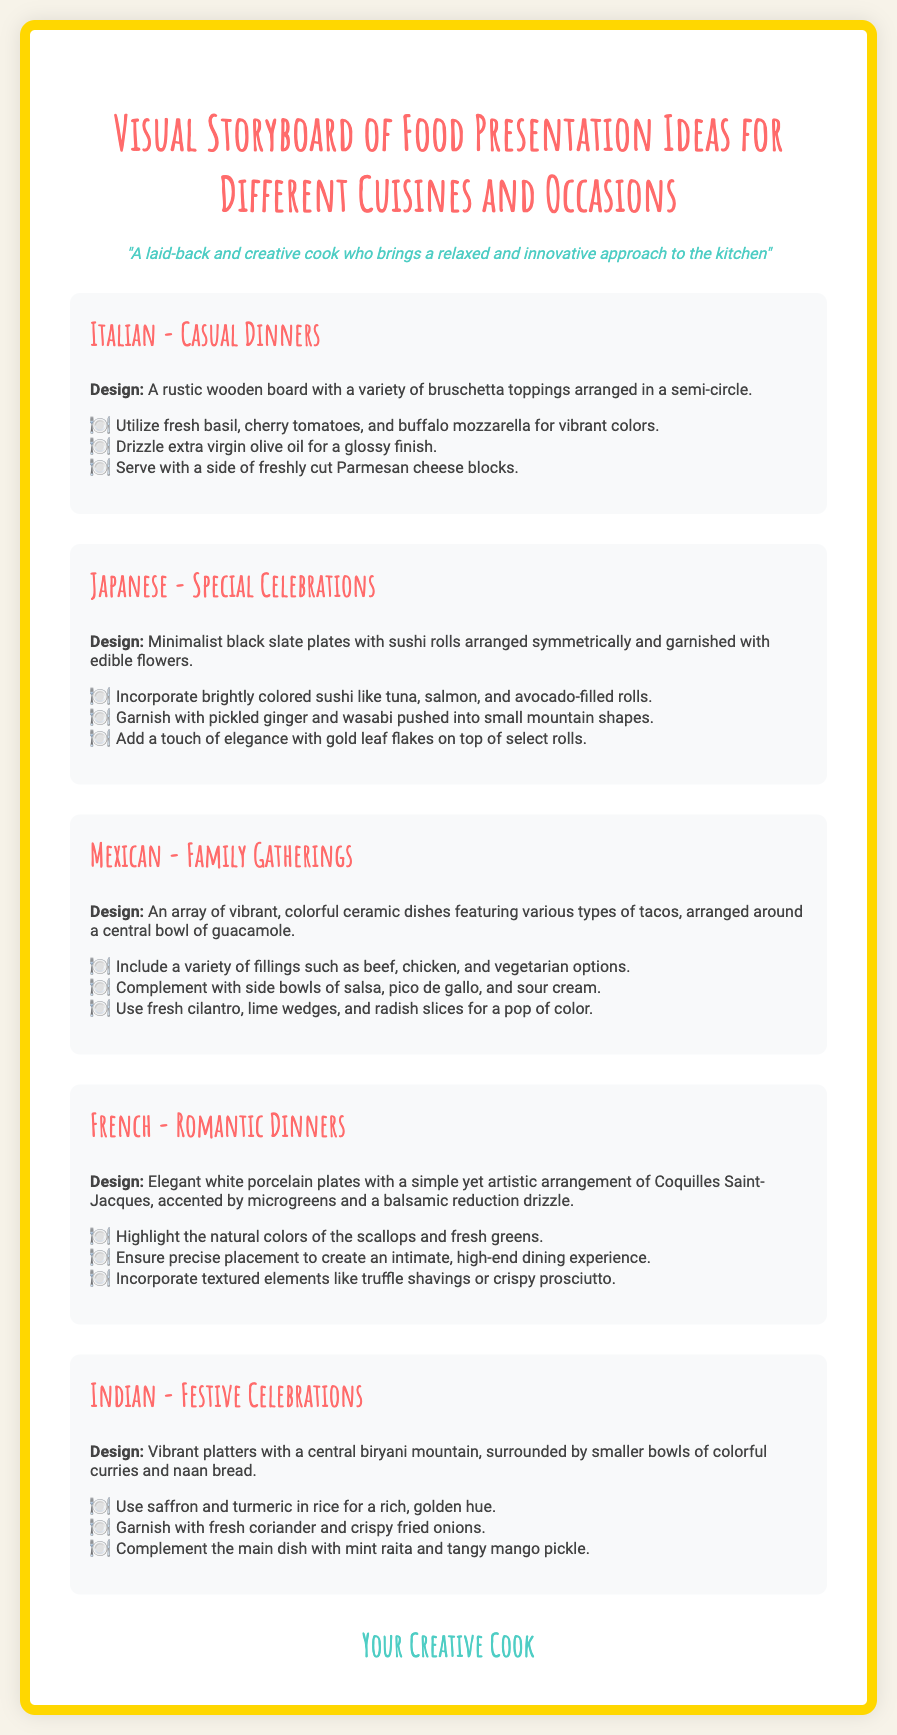what is the title of the document? The title of the document is given as "Visual Storyboard of Food Presentation Ideas for Different Cuisines and Occasions."
Answer: Visual Storyboard of Food Presentation Ideas for Different Cuisines and Occasions who is the persona described in the document? The persona is introduced in the document, describing their relaxed and innovative approach to cooking.
Answer: A laid-back and creative cook what cuisine is suggested for casual dinners? The document lists Italian cuisine for casual dinners along with its presentation ideas.
Answer: Italian how should sushi rolls be arranged according to the document? The document mentions that sushi rolls should be arranged symmetrically on minimalist black slate plates.
Answer: Symmetrically what main dish is featured in the Indian cuisine section? The document specifies the central dish in the Indian section as biryani.
Answer: Biryani which garnish is recommended for the French dish? The document suggests garnishing the French dish with microgreens.
Answer: Microgreens how many cuisines are covered in the document? The document details five different cuisines with presentation ideas.
Answer: Five what color is mainly associated with the Indian dish? The document refers to the use of saffron and turmeric for a rich, golden hue in the Indian cuisine section.
Answer: Golden which dish is highlighted for romantic dinners? The document features Coquilles Saint-Jacques as the highlighted dish for romantic dinners.
Answer: Coquilles Saint-Jacques 